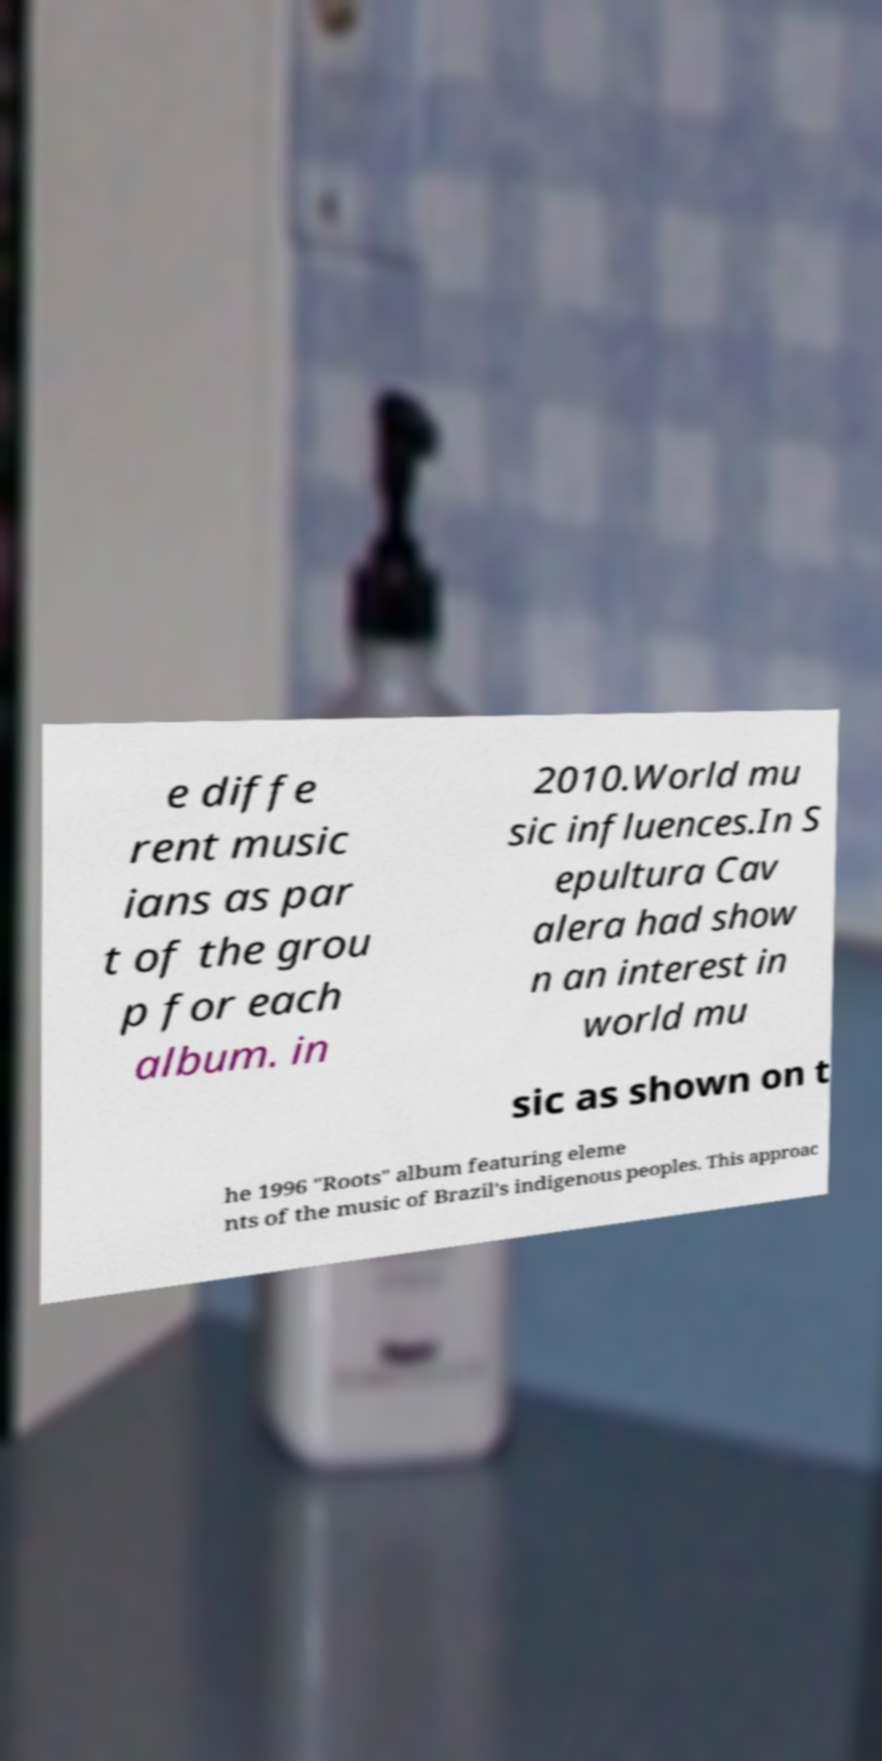For documentation purposes, I need the text within this image transcribed. Could you provide that? e diffe rent music ians as par t of the grou p for each album. in 2010.World mu sic influences.In S epultura Cav alera had show n an interest in world mu sic as shown on t he 1996 "Roots" album featuring eleme nts of the music of Brazil's indigenous peoples. This approac 